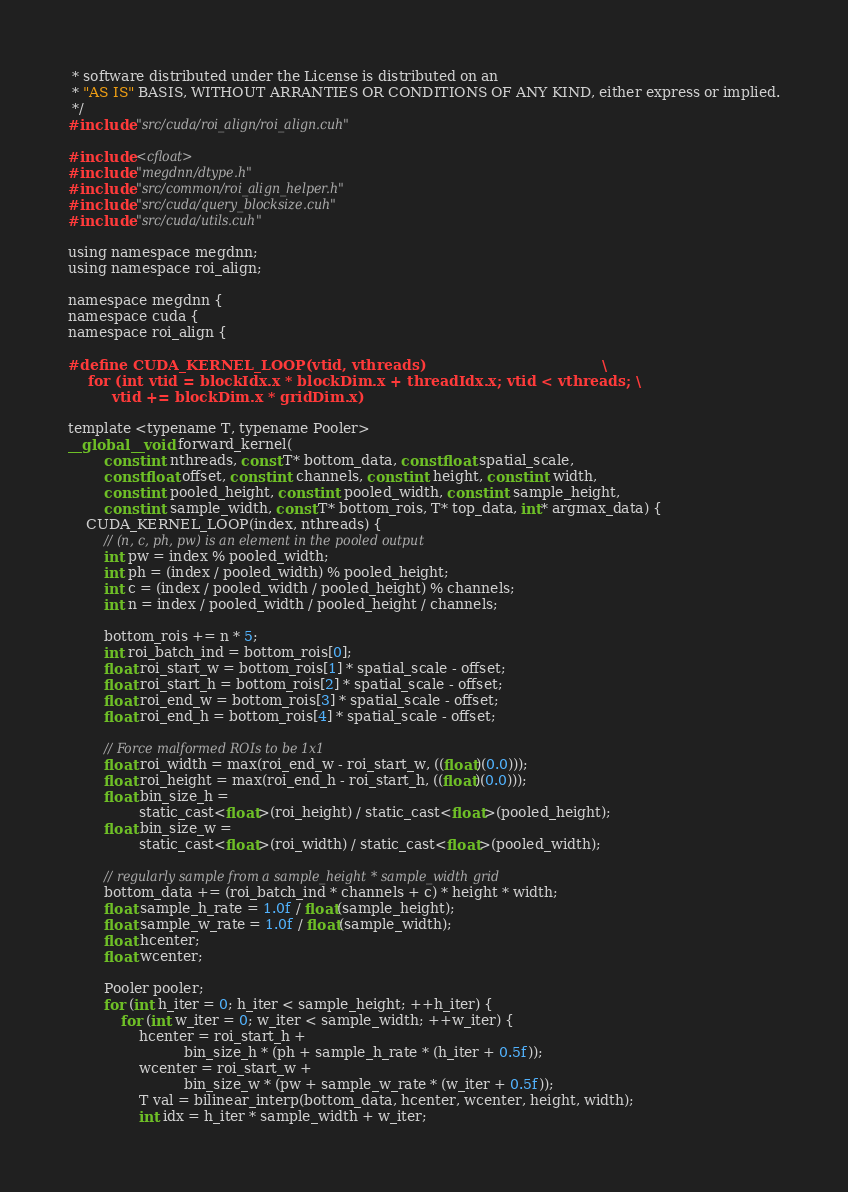Convert code to text. <code><loc_0><loc_0><loc_500><loc_500><_Cuda_> * software distributed under the License is distributed on an
 * "AS IS" BASIS, WITHOUT ARRANTIES OR CONDITIONS OF ANY KIND, either express or implied.
 */
#include "src/cuda/roi_align/roi_align.cuh"

#include <cfloat>
#include "megdnn/dtype.h"
#include "src/common/roi_align_helper.h"
#include "src/cuda/query_blocksize.cuh"
#include "src/cuda/utils.cuh"

using namespace megdnn;
using namespace roi_align;

namespace megdnn {
namespace cuda {
namespace roi_align {

#define CUDA_KERNEL_LOOP(vtid, vthreads)                                    \
    for (int vtid = blockIdx.x * blockDim.x + threadIdx.x; vtid < vthreads; \
         vtid += blockDim.x * gridDim.x)

template <typename T, typename Pooler>
__global__ void forward_kernel(
        const int nthreads, const T* bottom_data, const float spatial_scale,
        const float offset, const int channels, const int height, const int width,
        const int pooled_height, const int pooled_width, const int sample_height,
        const int sample_width, const T* bottom_rois, T* top_data, int* argmax_data) {
    CUDA_KERNEL_LOOP(index, nthreads) {
        // (n, c, ph, pw) is an element in the pooled output
        int pw = index % pooled_width;
        int ph = (index / pooled_width) % pooled_height;
        int c = (index / pooled_width / pooled_height) % channels;
        int n = index / pooled_width / pooled_height / channels;

        bottom_rois += n * 5;
        int roi_batch_ind = bottom_rois[0];
        float roi_start_w = bottom_rois[1] * spatial_scale - offset;
        float roi_start_h = bottom_rois[2] * spatial_scale - offset;
        float roi_end_w = bottom_rois[3] * spatial_scale - offset;
        float roi_end_h = bottom_rois[4] * spatial_scale - offset;

        // Force malformed ROIs to be 1x1
        float roi_width = max(roi_end_w - roi_start_w, ((float)(0.0)));
        float roi_height = max(roi_end_h - roi_start_h, ((float)(0.0)));
        float bin_size_h =
                static_cast<float>(roi_height) / static_cast<float>(pooled_height);
        float bin_size_w =
                static_cast<float>(roi_width) / static_cast<float>(pooled_width);

        // regularly sample from a sample_height * sample_width grid
        bottom_data += (roi_batch_ind * channels + c) * height * width;
        float sample_h_rate = 1.0f / float(sample_height);
        float sample_w_rate = 1.0f / float(sample_width);
        float hcenter;
        float wcenter;

        Pooler pooler;
        for (int h_iter = 0; h_iter < sample_height; ++h_iter) {
            for (int w_iter = 0; w_iter < sample_width; ++w_iter) {
                hcenter = roi_start_h +
                          bin_size_h * (ph + sample_h_rate * (h_iter + 0.5f));
                wcenter = roi_start_w +
                          bin_size_w * (pw + sample_w_rate * (w_iter + 0.5f));
                T val = bilinear_interp(bottom_data, hcenter, wcenter, height, width);
                int idx = h_iter * sample_width + w_iter;</code> 